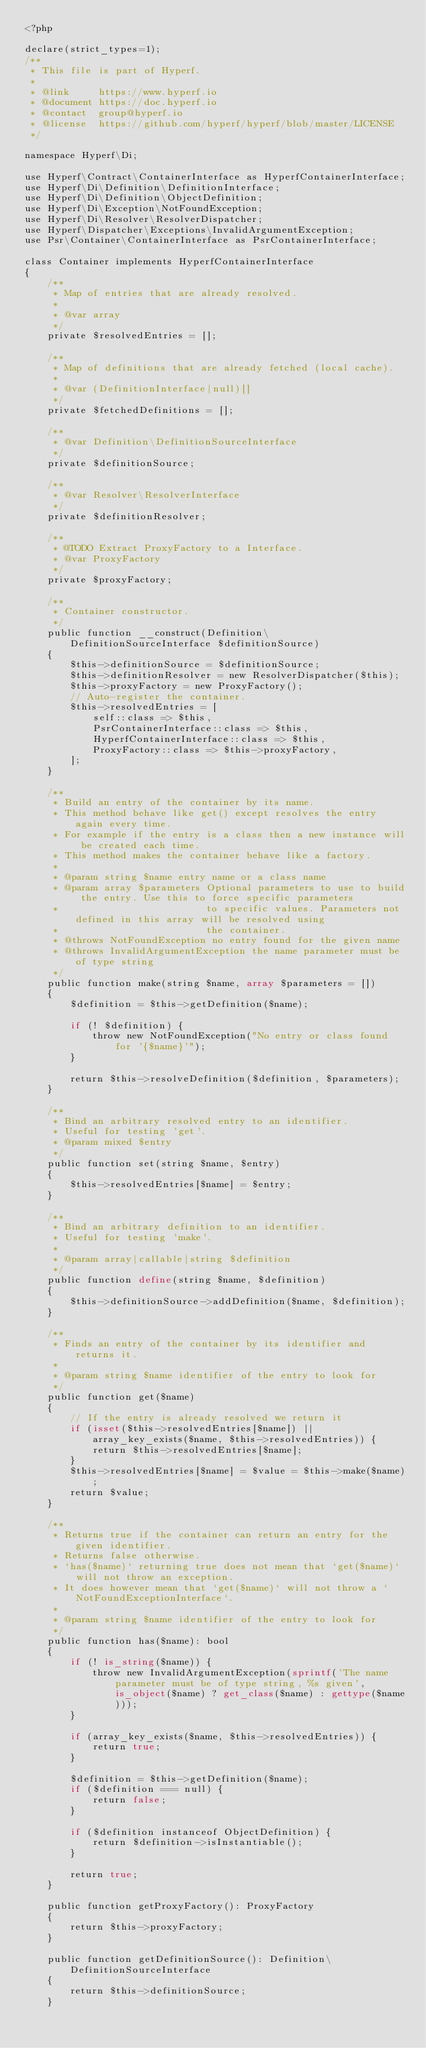<code> <loc_0><loc_0><loc_500><loc_500><_PHP_><?php

declare(strict_types=1);
/**
 * This file is part of Hyperf.
 *
 * @link     https://www.hyperf.io
 * @document https://doc.hyperf.io
 * @contact  group@hyperf.io
 * @license  https://github.com/hyperf/hyperf/blob/master/LICENSE
 */

namespace Hyperf\Di;

use Hyperf\Contract\ContainerInterface as HyperfContainerInterface;
use Hyperf\Di\Definition\DefinitionInterface;
use Hyperf\Di\Definition\ObjectDefinition;
use Hyperf\Di\Exception\NotFoundException;
use Hyperf\Di\Resolver\ResolverDispatcher;
use Hyperf\Dispatcher\Exceptions\InvalidArgumentException;
use Psr\Container\ContainerInterface as PsrContainerInterface;

class Container implements HyperfContainerInterface
{
    /**
     * Map of entries that are already resolved.
     *
     * @var array
     */
    private $resolvedEntries = [];

    /**
     * Map of definitions that are already fetched (local cache).
     *
     * @var (DefinitionInterface|null)[]
     */
    private $fetchedDefinitions = [];

    /**
     * @var Definition\DefinitionSourceInterface
     */
    private $definitionSource;

    /**
     * @var Resolver\ResolverInterface
     */
    private $definitionResolver;

    /**
     * @TODO Extract ProxyFactory to a Interface.
     * @var ProxyFactory
     */
    private $proxyFactory;

    /**
     * Container constructor.
     */
    public function __construct(Definition\DefinitionSourceInterface $definitionSource)
    {
        $this->definitionSource = $definitionSource;
        $this->definitionResolver = new ResolverDispatcher($this);
        $this->proxyFactory = new ProxyFactory();
        // Auto-register the container.
        $this->resolvedEntries = [
            self::class => $this,
            PsrContainerInterface::class => $this,
            HyperfContainerInterface::class => $this,
            ProxyFactory::class => $this->proxyFactory,
        ];
    }

    /**
     * Build an entry of the container by its name.
     * This method behave like get() except resolves the entry again every time.
     * For example if the entry is a class then a new instance will be created each time.
     * This method makes the container behave like a factory.
     *
     * @param string $name entry name or a class name
     * @param array $parameters Optional parameters to use to build the entry. Use this to force specific parameters
     *                          to specific values. Parameters not defined in this array will be resolved using
     *                          the container.
     * @throws NotFoundException no entry found for the given name
     * @throws InvalidArgumentException the name parameter must be of type string
     */
    public function make(string $name, array $parameters = [])
    {
        $definition = $this->getDefinition($name);

        if (! $definition) {
            throw new NotFoundException("No entry or class found for '{$name}'");
        }

        return $this->resolveDefinition($definition, $parameters);
    }

    /**
     * Bind an arbitrary resolved entry to an identifier.
     * Useful for testing 'get'.
     * @param mixed $entry
     */
    public function set(string $name, $entry)
    {
        $this->resolvedEntries[$name] = $entry;
    }

    /**
     * Bind an arbitrary definition to an identifier.
     * Useful for testing 'make'.
     *
     * @param array|callable|string $definition
     */
    public function define(string $name, $definition)
    {
        $this->definitionSource->addDefinition($name, $definition);
    }

    /**
     * Finds an entry of the container by its identifier and returns it.
     *
     * @param string $name identifier of the entry to look for
     */
    public function get($name)
    {
        // If the entry is already resolved we return it
        if (isset($this->resolvedEntries[$name]) || array_key_exists($name, $this->resolvedEntries)) {
            return $this->resolvedEntries[$name];
        }
        $this->resolvedEntries[$name] = $value = $this->make($name);
        return $value;
    }

    /**
     * Returns true if the container can return an entry for the given identifier.
     * Returns false otherwise.
     * `has($name)` returning true does not mean that `get($name)` will not throw an exception.
     * It does however mean that `get($name)` will not throw a `NotFoundExceptionInterface`.
     *
     * @param string $name identifier of the entry to look for
     */
    public function has($name): bool
    {
        if (! is_string($name)) {
            throw new InvalidArgumentException(sprintf('The name parameter must be of type string, %s given', is_object($name) ? get_class($name) : gettype($name)));
        }

        if (array_key_exists($name, $this->resolvedEntries)) {
            return true;
        }

        $definition = $this->getDefinition($name);
        if ($definition === null) {
            return false;
        }

        if ($definition instanceof ObjectDefinition) {
            return $definition->isInstantiable();
        }

        return true;
    }

    public function getProxyFactory(): ProxyFactory
    {
        return $this->proxyFactory;
    }

    public function getDefinitionSource(): Definition\DefinitionSourceInterface
    {
        return $this->definitionSource;
    }
</code> 